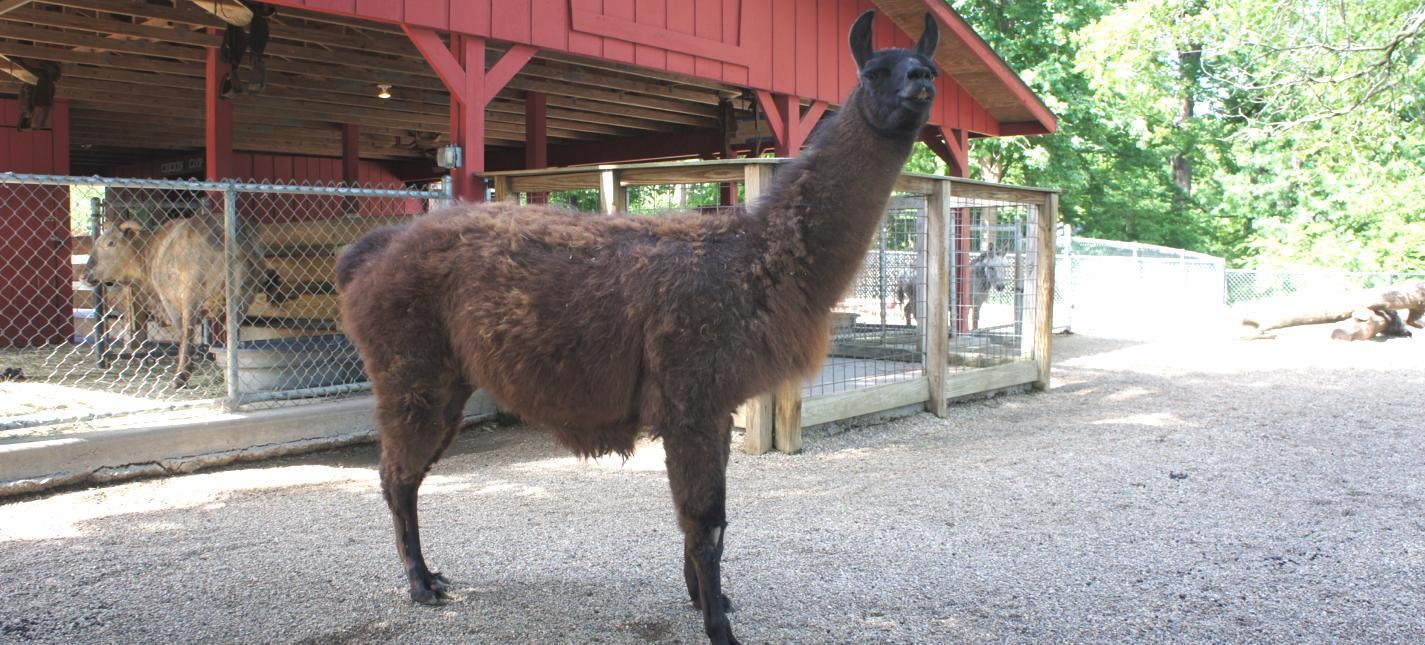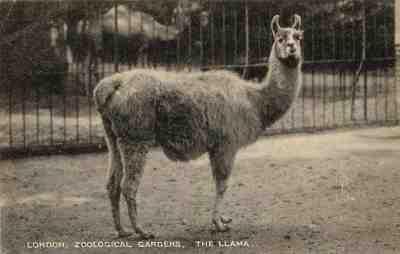The first image is the image on the left, the second image is the image on the right. Examine the images to the left and right. Is the description "All llama are standing with upright heads, and all llamas have their bodies turned rightward." accurate? Answer yes or no. Yes. The first image is the image on the left, the second image is the image on the right. Given the left and right images, does the statement "There are at most four llamas in the image pair." hold true? Answer yes or no. Yes. 